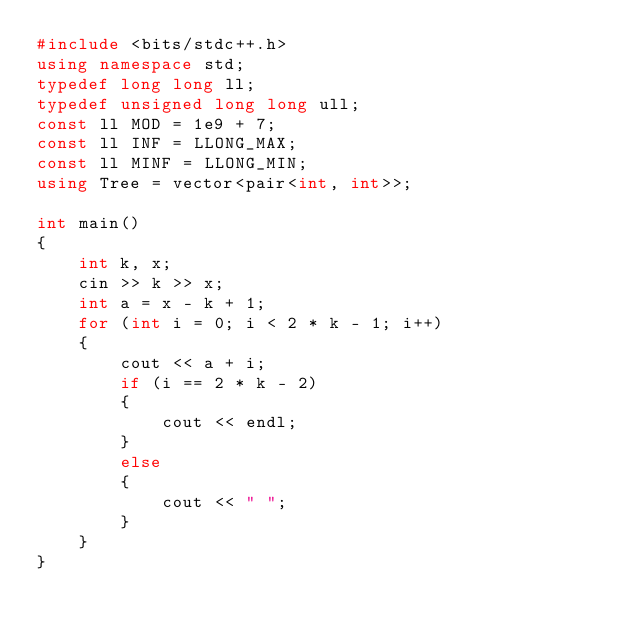<code> <loc_0><loc_0><loc_500><loc_500><_C++_>#include <bits/stdc++.h>
using namespace std;
typedef long long ll;
typedef unsigned long long ull;
const ll MOD = 1e9 + 7;
const ll INF = LLONG_MAX;
const ll MINF = LLONG_MIN;
using Tree = vector<pair<int, int>>;

int main()
{
    int k, x;
    cin >> k >> x;
    int a = x - k + 1;
    for (int i = 0; i < 2 * k - 1; i++)
    {
        cout << a + i;
        if (i == 2 * k - 2)
        {
            cout << endl;
        }
        else
        {
            cout << " ";
        }
    }
}</code> 